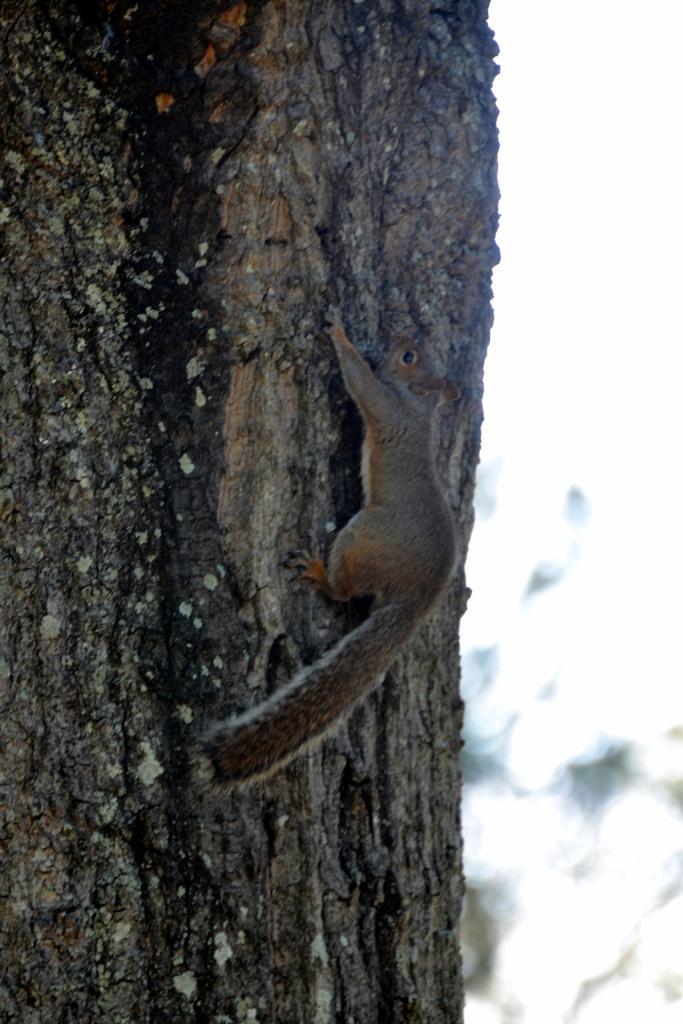In one or two sentences, can you explain what this image depicts? In this picture we can see a squirrel on a tree trunk and in the background we can see it is blurry. 